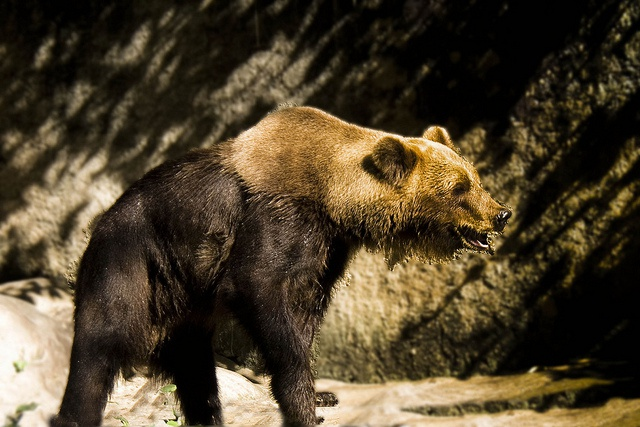Describe the objects in this image and their specific colors. I can see a bear in black, maroon, and tan tones in this image. 